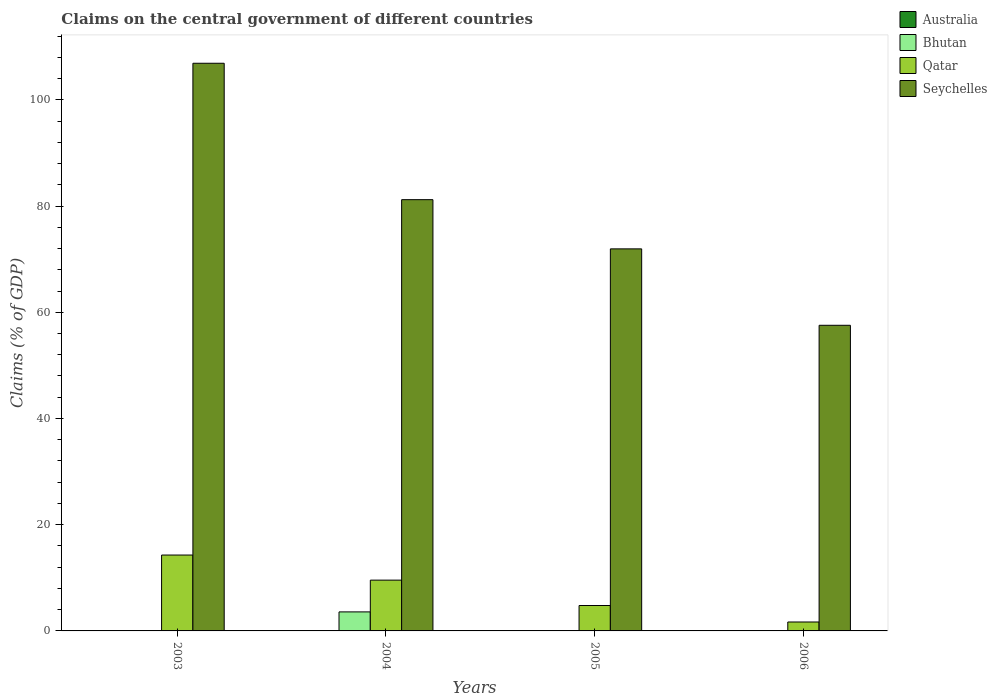Are the number of bars on each tick of the X-axis equal?
Offer a very short reply. No. How many bars are there on the 3rd tick from the left?
Your response must be concise. 2. In how many cases, is the number of bars for a given year not equal to the number of legend labels?
Offer a terse response. 4. Across all years, what is the maximum percentage of GDP claimed on the central government in Qatar?
Your answer should be very brief. 14.29. Across all years, what is the minimum percentage of GDP claimed on the central government in Australia?
Offer a terse response. 0. In which year was the percentage of GDP claimed on the central government in Seychelles maximum?
Your response must be concise. 2003. What is the total percentage of GDP claimed on the central government in Australia in the graph?
Your answer should be compact. 0. What is the difference between the percentage of GDP claimed on the central government in Qatar in 2004 and that in 2005?
Your answer should be very brief. 4.78. What is the difference between the percentage of GDP claimed on the central government in Seychelles in 2003 and the percentage of GDP claimed on the central government in Australia in 2006?
Offer a terse response. 106.88. What is the average percentage of GDP claimed on the central government in Seychelles per year?
Give a very brief answer. 79.39. In the year 2006, what is the difference between the percentage of GDP claimed on the central government in Seychelles and percentage of GDP claimed on the central government in Qatar?
Offer a very short reply. 55.86. What is the ratio of the percentage of GDP claimed on the central government in Qatar in 2003 to that in 2005?
Give a very brief answer. 2.99. Is the percentage of GDP claimed on the central government in Qatar in 2003 less than that in 2006?
Provide a succinct answer. No. Is the difference between the percentage of GDP claimed on the central government in Seychelles in 2004 and 2006 greater than the difference between the percentage of GDP claimed on the central government in Qatar in 2004 and 2006?
Provide a succinct answer. Yes. What is the difference between the highest and the second highest percentage of GDP claimed on the central government in Qatar?
Offer a very short reply. 4.72. What is the difference between the highest and the lowest percentage of GDP claimed on the central government in Qatar?
Ensure brevity in your answer.  12.61. In how many years, is the percentage of GDP claimed on the central government in Seychelles greater than the average percentage of GDP claimed on the central government in Seychelles taken over all years?
Make the answer very short. 2. Is the sum of the percentage of GDP claimed on the central government in Seychelles in 2003 and 2004 greater than the maximum percentage of GDP claimed on the central government in Australia across all years?
Provide a short and direct response. Yes. Is it the case that in every year, the sum of the percentage of GDP claimed on the central government in Qatar and percentage of GDP claimed on the central government in Bhutan is greater than the sum of percentage of GDP claimed on the central government in Australia and percentage of GDP claimed on the central government in Seychelles?
Ensure brevity in your answer.  No. Is it the case that in every year, the sum of the percentage of GDP claimed on the central government in Bhutan and percentage of GDP claimed on the central government in Seychelles is greater than the percentage of GDP claimed on the central government in Qatar?
Provide a short and direct response. Yes. How many years are there in the graph?
Provide a short and direct response. 4. What is the difference between two consecutive major ticks on the Y-axis?
Give a very brief answer. 20. Does the graph contain any zero values?
Provide a short and direct response. Yes. Does the graph contain grids?
Provide a short and direct response. No. How many legend labels are there?
Keep it short and to the point. 4. What is the title of the graph?
Offer a terse response. Claims on the central government of different countries. What is the label or title of the X-axis?
Provide a succinct answer. Years. What is the label or title of the Y-axis?
Provide a short and direct response. Claims (% of GDP). What is the Claims (% of GDP) in Qatar in 2003?
Make the answer very short. 14.29. What is the Claims (% of GDP) of Seychelles in 2003?
Make the answer very short. 106.88. What is the Claims (% of GDP) in Bhutan in 2004?
Provide a succinct answer. 3.58. What is the Claims (% of GDP) of Qatar in 2004?
Give a very brief answer. 9.56. What is the Claims (% of GDP) of Seychelles in 2004?
Offer a very short reply. 81.2. What is the Claims (% of GDP) of Bhutan in 2005?
Your answer should be very brief. 0. What is the Claims (% of GDP) of Qatar in 2005?
Provide a short and direct response. 4.79. What is the Claims (% of GDP) of Seychelles in 2005?
Your response must be concise. 71.94. What is the Claims (% of GDP) of Qatar in 2006?
Your answer should be compact. 1.68. What is the Claims (% of GDP) of Seychelles in 2006?
Your answer should be very brief. 57.54. Across all years, what is the maximum Claims (% of GDP) of Bhutan?
Your answer should be very brief. 3.58. Across all years, what is the maximum Claims (% of GDP) in Qatar?
Keep it short and to the point. 14.29. Across all years, what is the maximum Claims (% of GDP) of Seychelles?
Provide a succinct answer. 106.88. Across all years, what is the minimum Claims (% of GDP) of Bhutan?
Your response must be concise. 0. Across all years, what is the minimum Claims (% of GDP) in Qatar?
Keep it short and to the point. 1.68. Across all years, what is the minimum Claims (% of GDP) of Seychelles?
Keep it short and to the point. 57.54. What is the total Claims (% of GDP) of Australia in the graph?
Offer a terse response. 0. What is the total Claims (% of GDP) of Bhutan in the graph?
Offer a terse response. 3.58. What is the total Claims (% of GDP) of Qatar in the graph?
Keep it short and to the point. 30.32. What is the total Claims (% of GDP) in Seychelles in the graph?
Your answer should be compact. 317.56. What is the difference between the Claims (% of GDP) of Qatar in 2003 and that in 2004?
Ensure brevity in your answer.  4.72. What is the difference between the Claims (% of GDP) in Seychelles in 2003 and that in 2004?
Make the answer very short. 25.68. What is the difference between the Claims (% of GDP) of Qatar in 2003 and that in 2005?
Make the answer very short. 9.5. What is the difference between the Claims (% of GDP) of Seychelles in 2003 and that in 2005?
Give a very brief answer. 34.95. What is the difference between the Claims (% of GDP) in Qatar in 2003 and that in 2006?
Your response must be concise. 12.61. What is the difference between the Claims (% of GDP) in Seychelles in 2003 and that in 2006?
Offer a terse response. 49.34. What is the difference between the Claims (% of GDP) in Qatar in 2004 and that in 2005?
Provide a succinct answer. 4.78. What is the difference between the Claims (% of GDP) in Seychelles in 2004 and that in 2005?
Offer a very short reply. 9.26. What is the difference between the Claims (% of GDP) in Qatar in 2004 and that in 2006?
Offer a very short reply. 7.88. What is the difference between the Claims (% of GDP) of Seychelles in 2004 and that in 2006?
Make the answer very short. 23.65. What is the difference between the Claims (% of GDP) of Qatar in 2005 and that in 2006?
Your answer should be very brief. 3.11. What is the difference between the Claims (% of GDP) of Seychelles in 2005 and that in 2006?
Your response must be concise. 14.39. What is the difference between the Claims (% of GDP) in Qatar in 2003 and the Claims (% of GDP) in Seychelles in 2004?
Offer a terse response. -66.91. What is the difference between the Claims (% of GDP) in Qatar in 2003 and the Claims (% of GDP) in Seychelles in 2005?
Make the answer very short. -57.65. What is the difference between the Claims (% of GDP) of Qatar in 2003 and the Claims (% of GDP) of Seychelles in 2006?
Keep it short and to the point. -43.26. What is the difference between the Claims (% of GDP) of Bhutan in 2004 and the Claims (% of GDP) of Qatar in 2005?
Give a very brief answer. -1.2. What is the difference between the Claims (% of GDP) of Bhutan in 2004 and the Claims (% of GDP) of Seychelles in 2005?
Provide a short and direct response. -68.35. What is the difference between the Claims (% of GDP) of Qatar in 2004 and the Claims (% of GDP) of Seychelles in 2005?
Your response must be concise. -62.37. What is the difference between the Claims (% of GDP) of Bhutan in 2004 and the Claims (% of GDP) of Qatar in 2006?
Keep it short and to the point. 1.9. What is the difference between the Claims (% of GDP) in Bhutan in 2004 and the Claims (% of GDP) in Seychelles in 2006?
Keep it short and to the point. -53.96. What is the difference between the Claims (% of GDP) in Qatar in 2004 and the Claims (% of GDP) in Seychelles in 2006?
Your response must be concise. -47.98. What is the difference between the Claims (% of GDP) of Qatar in 2005 and the Claims (% of GDP) of Seychelles in 2006?
Your answer should be very brief. -52.76. What is the average Claims (% of GDP) in Bhutan per year?
Provide a succinct answer. 0.9. What is the average Claims (% of GDP) in Qatar per year?
Your answer should be very brief. 7.58. What is the average Claims (% of GDP) of Seychelles per year?
Give a very brief answer. 79.39. In the year 2003, what is the difference between the Claims (% of GDP) in Qatar and Claims (% of GDP) in Seychelles?
Make the answer very short. -92.6. In the year 2004, what is the difference between the Claims (% of GDP) of Bhutan and Claims (% of GDP) of Qatar?
Offer a terse response. -5.98. In the year 2004, what is the difference between the Claims (% of GDP) of Bhutan and Claims (% of GDP) of Seychelles?
Provide a succinct answer. -77.62. In the year 2004, what is the difference between the Claims (% of GDP) in Qatar and Claims (% of GDP) in Seychelles?
Provide a short and direct response. -71.64. In the year 2005, what is the difference between the Claims (% of GDP) in Qatar and Claims (% of GDP) in Seychelles?
Ensure brevity in your answer.  -67.15. In the year 2006, what is the difference between the Claims (% of GDP) in Qatar and Claims (% of GDP) in Seychelles?
Provide a succinct answer. -55.86. What is the ratio of the Claims (% of GDP) in Qatar in 2003 to that in 2004?
Your response must be concise. 1.49. What is the ratio of the Claims (% of GDP) in Seychelles in 2003 to that in 2004?
Provide a short and direct response. 1.32. What is the ratio of the Claims (% of GDP) in Qatar in 2003 to that in 2005?
Ensure brevity in your answer.  2.98. What is the ratio of the Claims (% of GDP) of Seychelles in 2003 to that in 2005?
Give a very brief answer. 1.49. What is the ratio of the Claims (% of GDP) in Qatar in 2003 to that in 2006?
Keep it short and to the point. 8.5. What is the ratio of the Claims (% of GDP) in Seychelles in 2003 to that in 2006?
Provide a short and direct response. 1.86. What is the ratio of the Claims (% of GDP) of Qatar in 2004 to that in 2005?
Offer a terse response. 2. What is the ratio of the Claims (% of GDP) in Seychelles in 2004 to that in 2005?
Offer a terse response. 1.13. What is the ratio of the Claims (% of GDP) in Qatar in 2004 to that in 2006?
Your answer should be compact. 5.69. What is the ratio of the Claims (% of GDP) of Seychelles in 2004 to that in 2006?
Provide a short and direct response. 1.41. What is the ratio of the Claims (% of GDP) in Qatar in 2005 to that in 2006?
Offer a terse response. 2.85. What is the ratio of the Claims (% of GDP) of Seychelles in 2005 to that in 2006?
Offer a terse response. 1.25. What is the difference between the highest and the second highest Claims (% of GDP) of Qatar?
Provide a succinct answer. 4.72. What is the difference between the highest and the second highest Claims (% of GDP) of Seychelles?
Your answer should be compact. 25.68. What is the difference between the highest and the lowest Claims (% of GDP) in Bhutan?
Your answer should be compact. 3.58. What is the difference between the highest and the lowest Claims (% of GDP) of Qatar?
Offer a very short reply. 12.61. What is the difference between the highest and the lowest Claims (% of GDP) in Seychelles?
Provide a short and direct response. 49.34. 